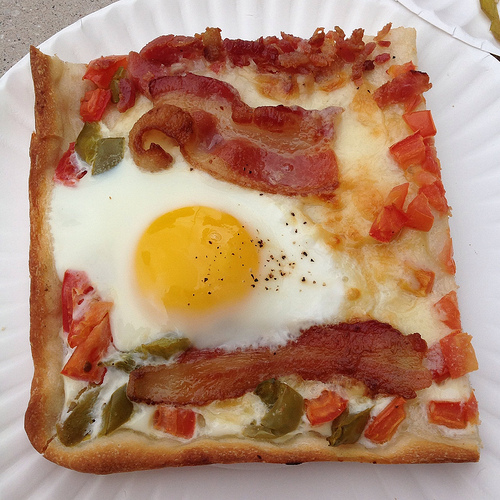What ingredients are visible on this pizza section showing the region [0.3, 0.2, 0.5, 0.5]? In this specific area, you can see a rich, runny egg yolk and a portion of sharp and vibrant diced green peppers adding a pop of flavor and color. Is there any specific ingredient that looks like it is added last on top of everything else? The finely chopped tomatoes and scattered herbs are likely added last to preserve their fresh, juicy texture and vibrant color atop the pizza. 